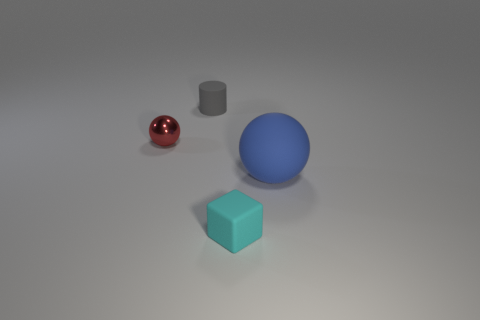Add 1 blue matte blocks. How many objects exist? 5 Add 1 tiny cyan cubes. How many tiny cyan cubes exist? 2 Subtract 1 cyan cubes. How many objects are left? 3 Subtract all cylinders. How many objects are left? 3 Subtract all tiny blue cubes. Subtract all blue spheres. How many objects are left? 3 Add 2 small shiny balls. How many small shiny balls are left? 3 